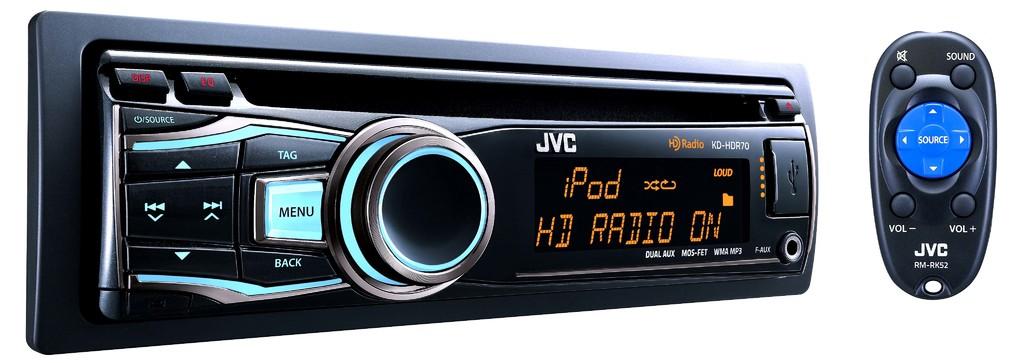What is the tuner set to?
Provide a succinct answer. Ipod. 